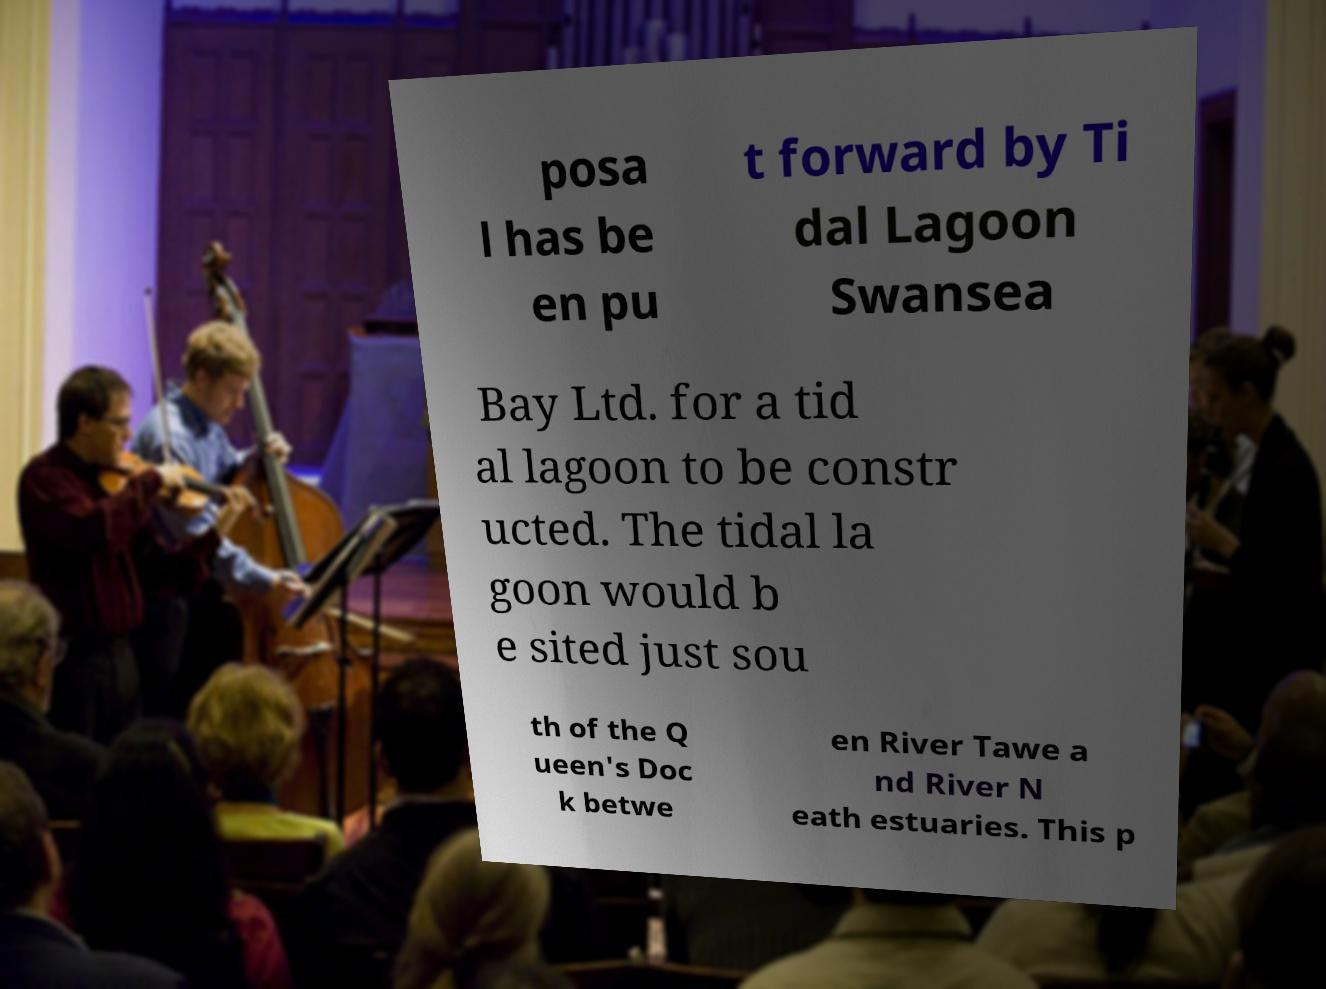For documentation purposes, I need the text within this image transcribed. Could you provide that? posa l has be en pu t forward by Ti dal Lagoon Swansea Bay Ltd. for a tid al lagoon to be constr ucted. The tidal la goon would b e sited just sou th of the Q ueen's Doc k betwe en River Tawe a nd River N eath estuaries. This p 